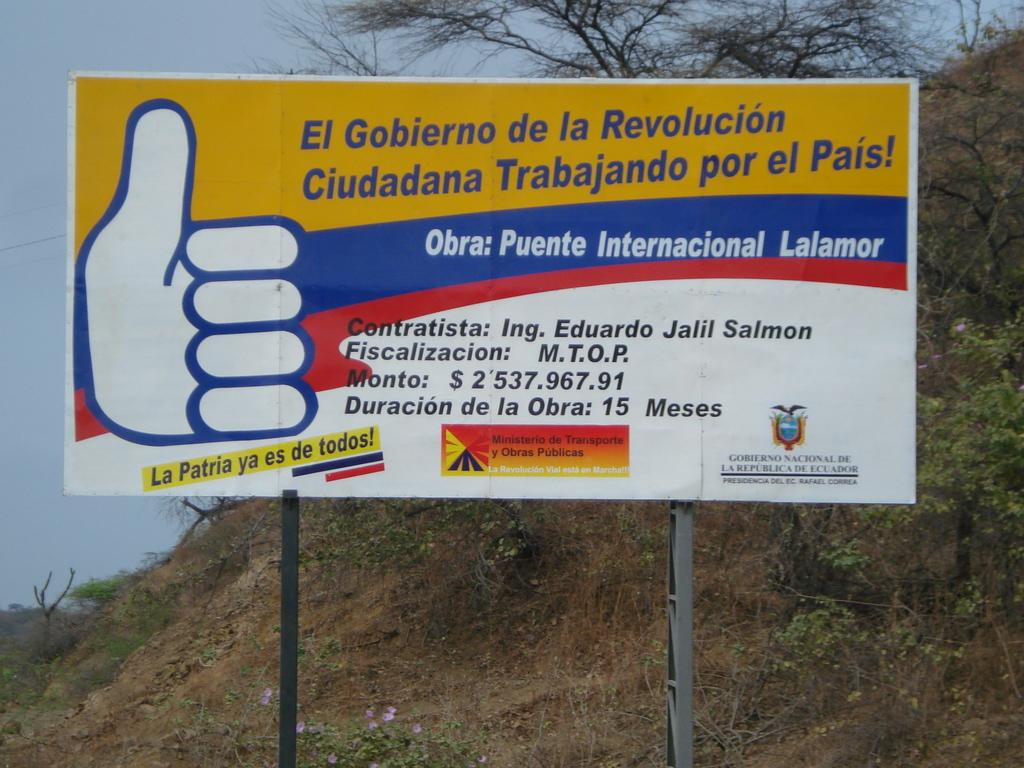<image>
Present a compact description of the photo's key features. A signboard from Eduardo Jalil Salmon is in red, white, yellow, and blue. 